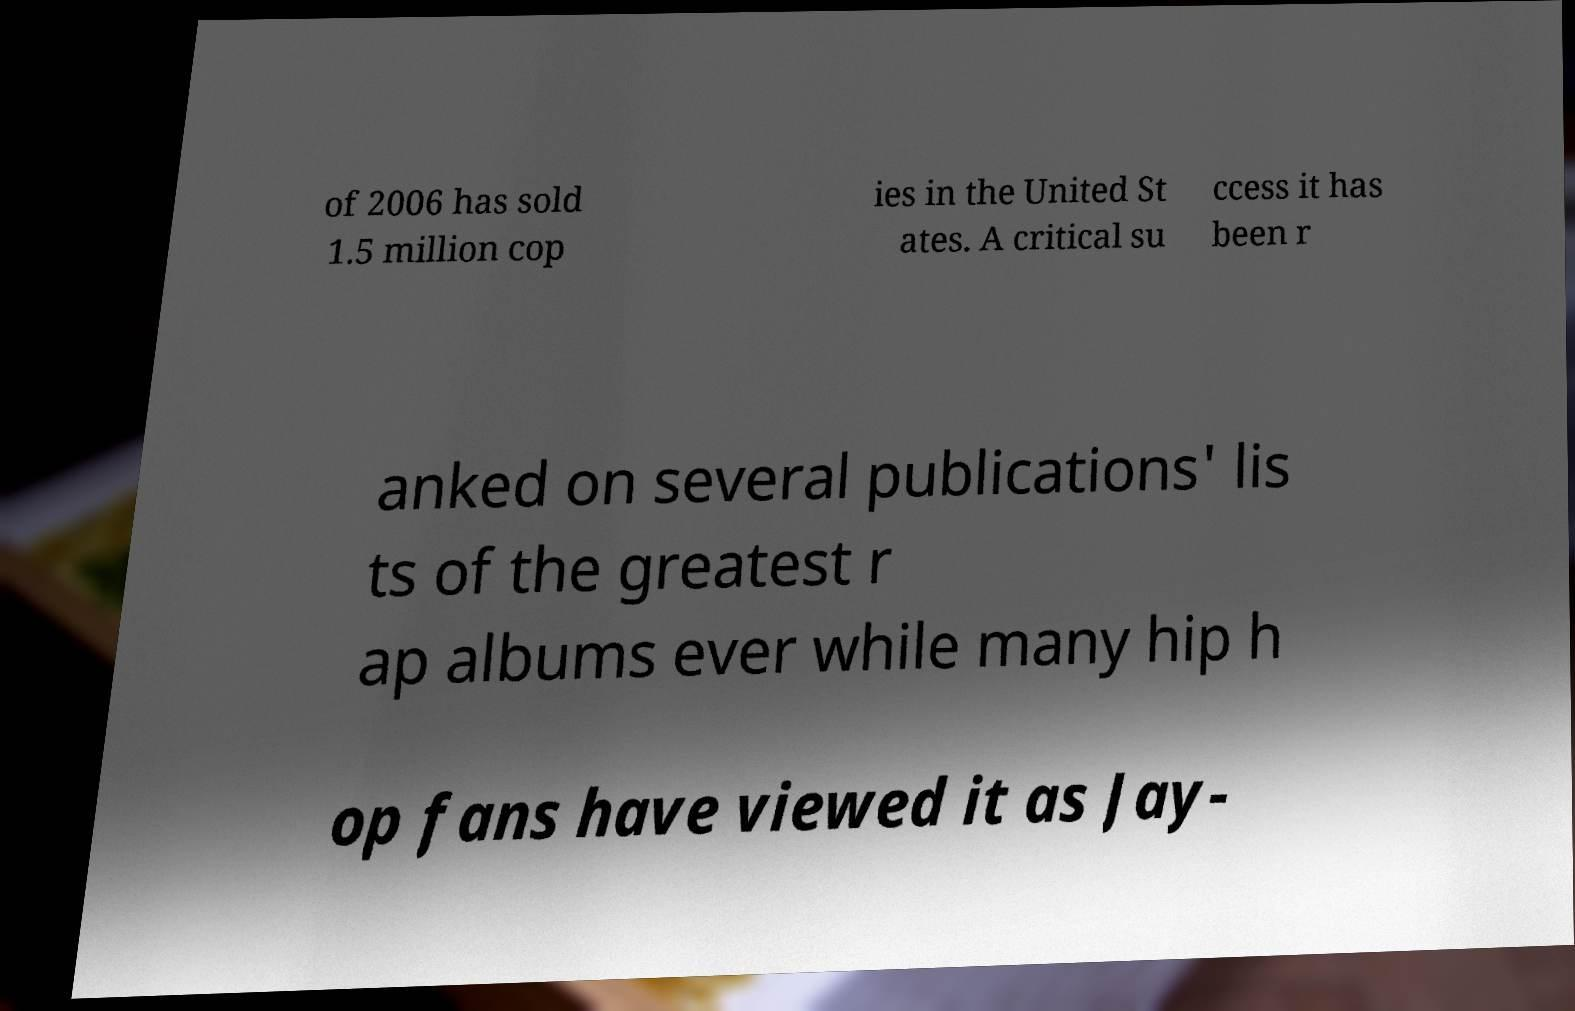Please read and relay the text visible in this image. What does it say? of 2006 has sold 1.5 million cop ies in the United St ates. A critical su ccess it has been r anked on several publications' lis ts of the greatest r ap albums ever while many hip h op fans have viewed it as Jay- 